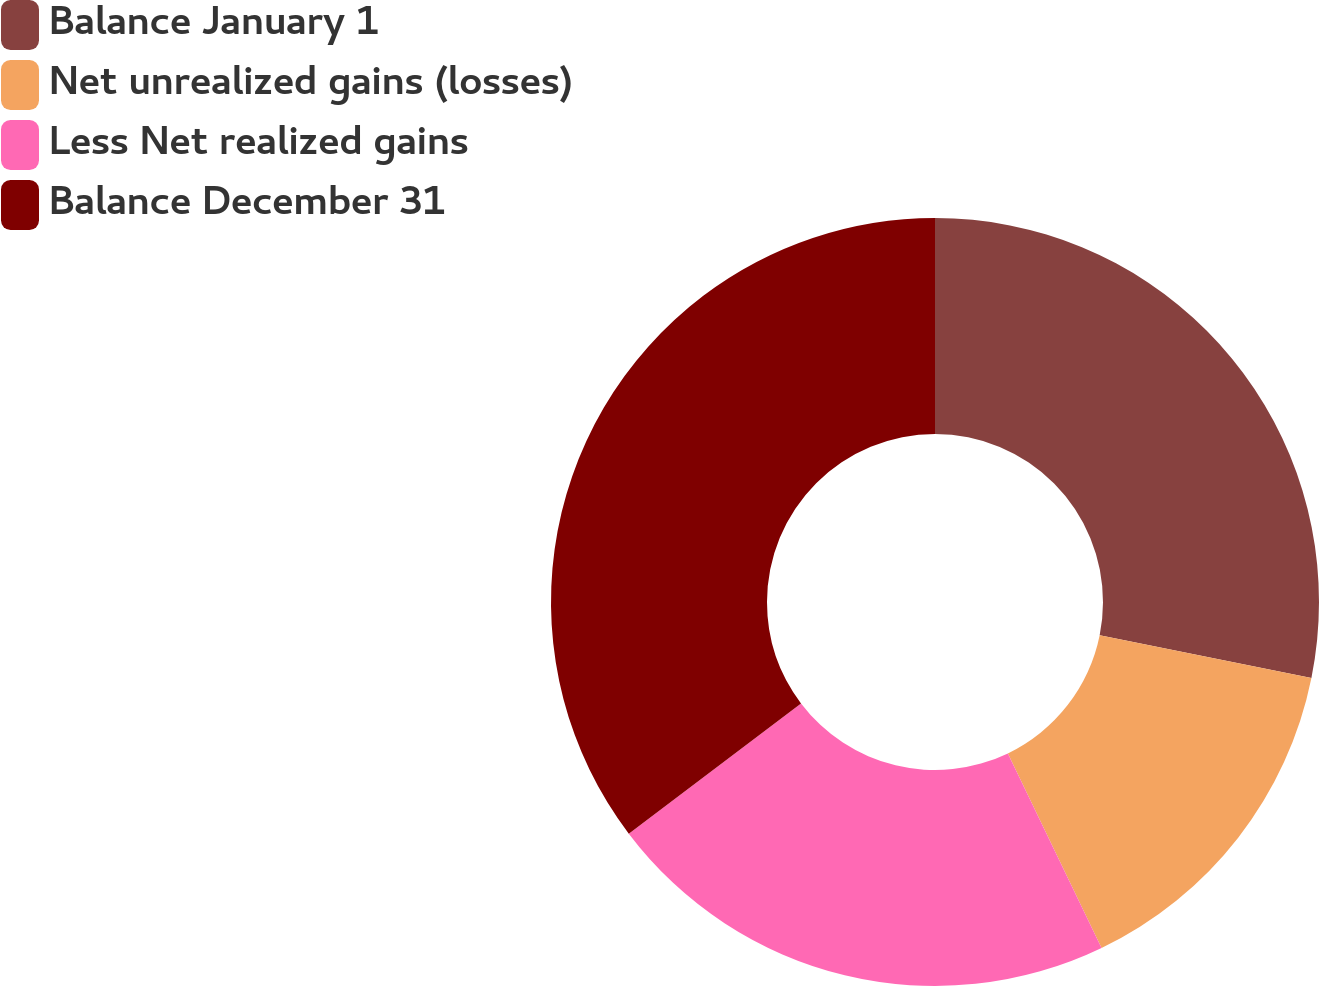Convert chart. <chart><loc_0><loc_0><loc_500><loc_500><pie_chart><fcel>Balance January 1<fcel>Net unrealized gains (losses)<fcel>Less Net realized gains<fcel>Balance December 31<nl><fcel>28.17%<fcel>14.69%<fcel>21.83%<fcel>35.31%<nl></chart> 